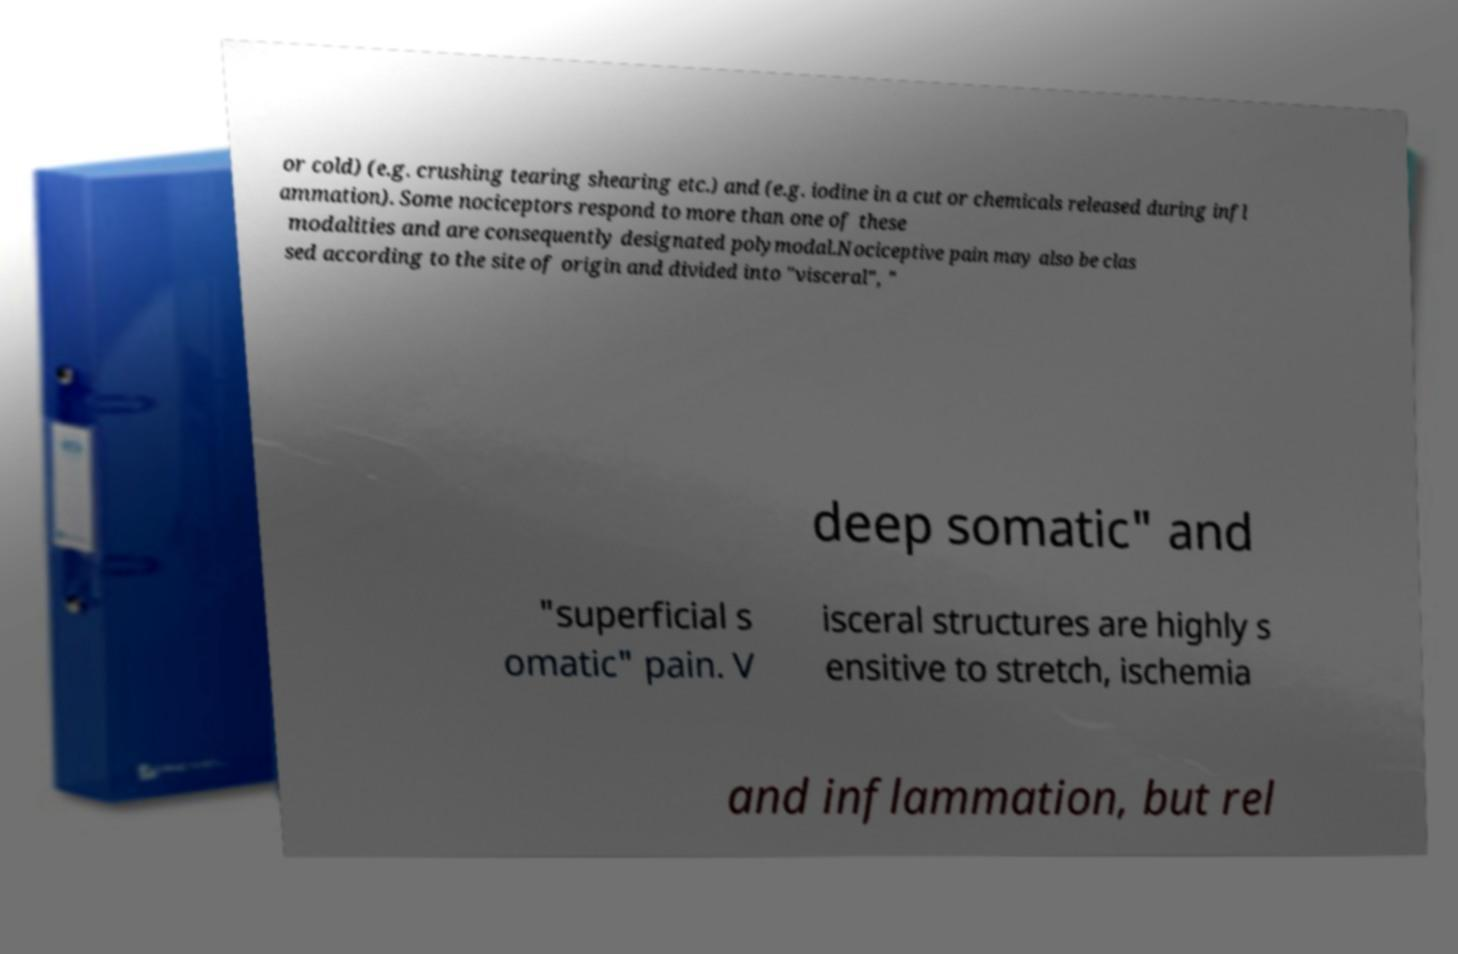I need the written content from this picture converted into text. Can you do that? or cold) (e.g. crushing tearing shearing etc.) and (e.g. iodine in a cut or chemicals released during infl ammation). Some nociceptors respond to more than one of these modalities and are consequently designated polymodal.Nociceptive pain may also be clas sed according to the site of origin and divided into "visceral", " deep somatic" and "superficial s omatic" pain. V isceral structures are highly s ensitive to stretch, ischemia and inflammation, but rel 